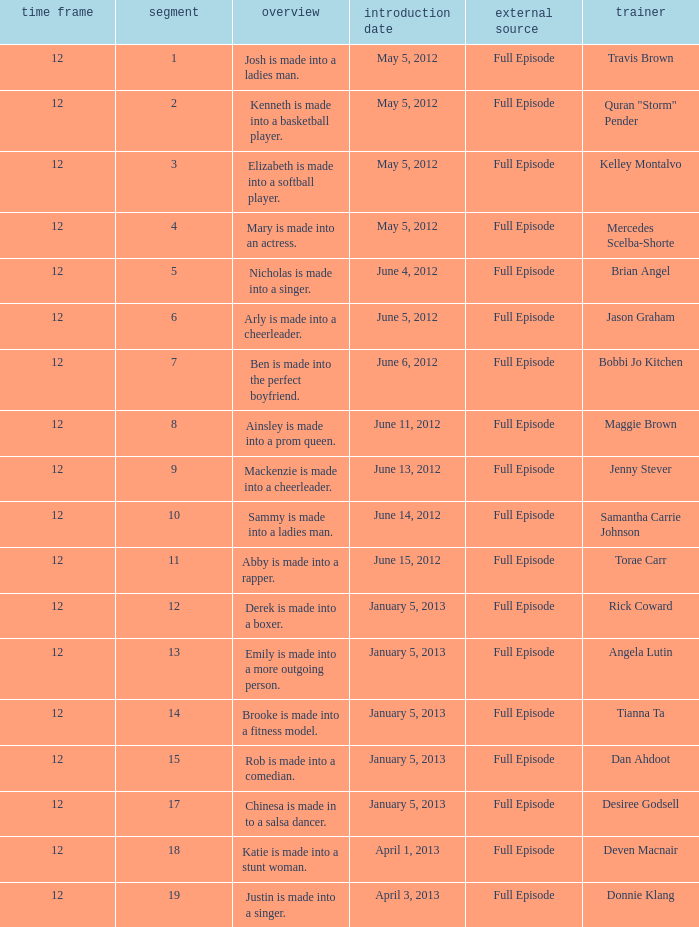Name the episode summary for torae carr Abby is made into a rapper. 